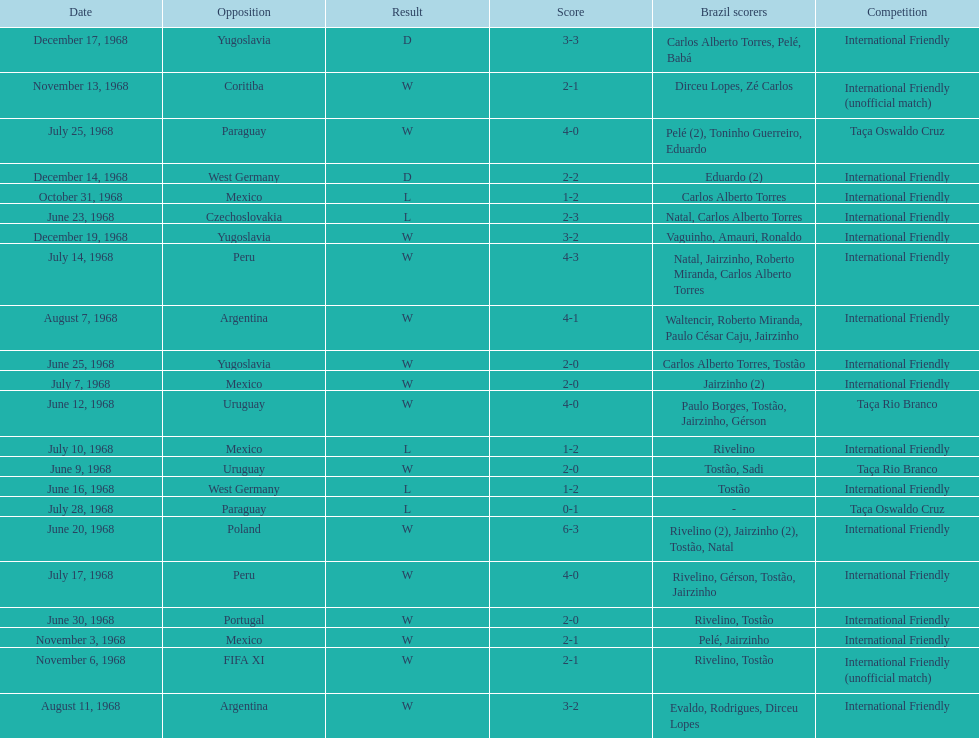What year has the highest scoring game? 1968. 